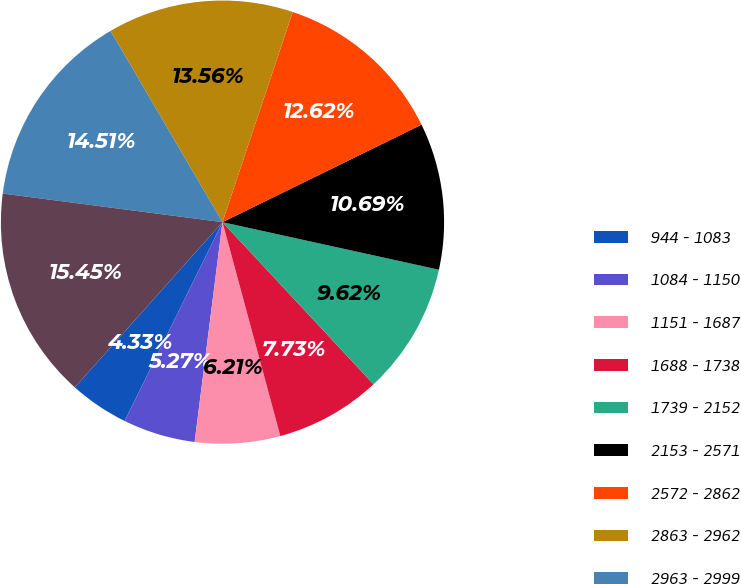<chart> <loc_0><loc_0><loc_500><loc_500><pie_chart><fcel>944 - 1083<fcel>1084 - 1150<fcel>1151 - 1687<fcel>1688 - 1738<fcel>1739 - 2152<fcel>2153 - 2571<fcel>2572 - 2862<fcel>2863 - 2962<fcel>2963 - 2999<fcel>3000 - 3000<nl><fcel>4.33%<fcel>5.27%<fcel>6.21%<fcel>7.73%<fcel>9.62%<fcel>10.69%<fcel>12.62%<fcel>13.56%<fcel>14.51%<fcel>15.45%<nl></chart> 